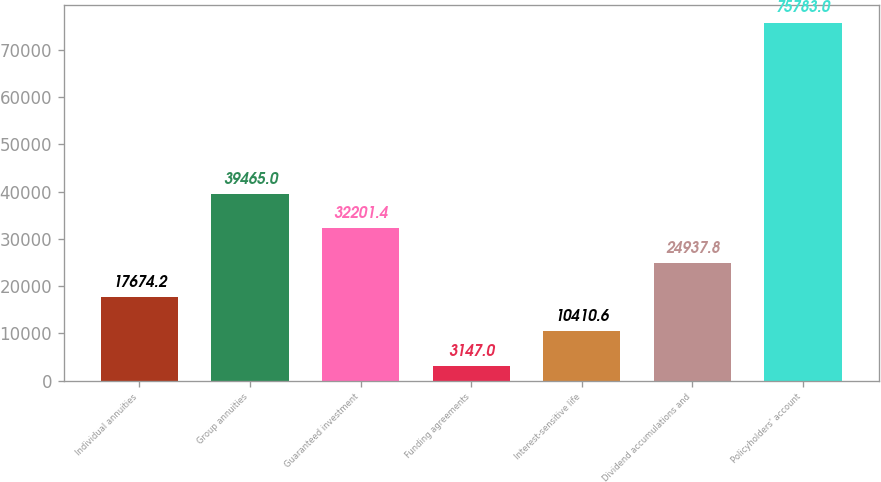Convert chart. <chart><loc_0><loc_0><loc_500><loc_500><bar_chart><fcel>Individual annuities<fcel>Group annuities<fcel>Guaranteed investment<fcel>Funding agreements<fcel>Interest-sensitive life<fcel>Dividend accumulations and<fcel>Policyholders' account<nl><fcel>17674.2<fcel>39465<fcel>32201.4<fcel>3147<fcel>10410.6<fcel>24937.8<fcel>75783<nl></chart> 